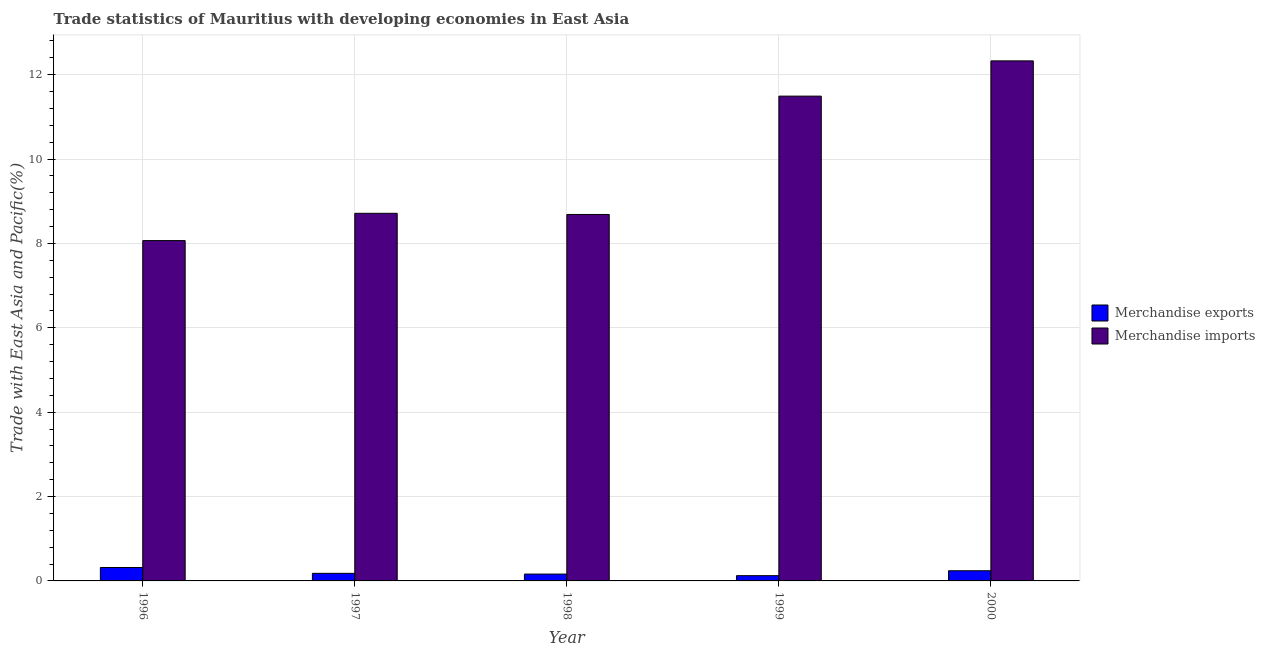How many different coloured bars are there?
Your answer should be compact. 2. Are the number of bars per tick equal to the number of legend labels?
Offer a very short reply. Yes. Are the number of bars on each tick of the X-axis equal?
Make the answer very short. Yes. How many bars are there on the 4th tick from the left?
Offer a terse response. 2. How many bars are there on the 2nd tick from the right?
Provide a succinct answer. 2. What is the merchandise exports in 2000?
Offer a terse response. 0.24. Across all years, what is the maximum merchandise imports?
Make the answer very short. 12.33. Across all years, what is the minimum merchandise imports?
Give a very brief answer. 8.07. In which year was the merchandise imports minimum?
Give a very brief answer. 1996. What is the total merchandise imports in the graph?
Make the answer very short. 49.28. What is the difference between the merchandise imports in 1997 and that in 1999?
Offer a very short reply. -2.78. What is the difference between the merchandise exports in 2000 and the merchandise imports in 1997?
Your answer should be very brief. 0.06. What is the average merchandise exports per year?
Keep it short and to the point. 0.21. What is the ratio of the merchandise imports in 1996 to that in 2000?
Offer a very short reply. 0.65. Is the merchandise exports in 1998 less than that in 1999?
Your answer should be compact. No. What is the difference between the highest and the second highest merchandise imports?
Provide a succinct answer. 0.84. What is the difference between the highest and the lowest merchandise exports?
Your answer should be very brief. 0.19. In how many years, is the merchandise exports greater than the average merchandise exports taken over all years?
Give a very brief answer. 2. Is the sum of the merchandise exports in 1996 and 1997 greater than the maximum merchandise imports across all years?
Offer a terse response. Yes. Are all the bars in the graph horizontal?
Make the answer very short. No. How many years are there in the graph?
Offer a very short reply. 5. What is the difference between two consecutive major ticks on the Y-axis?
Offer a very short reply. 2. Does the graph contain any zero values?
Make the answer very short. No. How are the legend labels stacked?
Offer a very short reply. Vertical. What is the title of the graph?
Ensure brevity in your answer.  Trade statistics of Mauritius with developing economies in East Asia. What is the label or title of the X-axis?
Your answer should be compact. Year. What is the label or title of the Y-axis?
Your answer should be very brief. Trade with East Asia and Pacific(%). What is the Trade with East Asia and Pacific(%) in Merchandise exports in 1996?
Provide a succinct answer. 0.32. What is the Trade with East Asia and Pacific(%) of Merchandise imports in 1996?
Ensure brevity in your answer.  8.07. What is the Trade with East Asia and Pacific(%) in Merchandise exports in 1997?
Give a very brief answer. 0.18. What is the Trade with East Asia and Pacific(%) in Merchandise imports in 1997?
Your response must be concise. 8.71. What is the Trade with East Asia and Pacific(%) in Merchandise exports in 1998?
Your answer should be compact. 0.16. What is the Trade with East Asia and Pacific(%) of Merchandise imports in 1998?
Offer a very short reply. 8.69. What is the Trade with East Asia and Pacific(%) of Merchandise exports in 1999?
Offer a terse response. 0.12. What is the Trade with East Asia and Pacific(%) in Merchandise imports in 1999?
Your answer should be compact. 11.49. What is the Trade with East Asia and Pacific(%) in Merchandise exports in 2000?
Keep it short and to the point. 0.24. What is the Trade with East Asia and Pacific(%) of Merchandise imports in 2000?
Your answer should be compact. 12.33. Across all years, what is the maximum Trade with East Asia and Pacific(%) in Merchandise exports?
Provide a succinct answer. 0.32. Across all years, what is the maximum Trade with East Asia and Pacific(%) in Merchandise imports?
Provide a succinct answer. 12.33. Across all years, what is the minimum Trade with East Asia and Pacific(%) of Merchandise exports?
Provide a short and direct response. 0.12. Across all years, what is the minimum Trade with East Asia and Pacific(%) of Merchandise imports?
Your answer should be compact. 8.07. What is the total Trade with East Asia and Pacific(%) of Merchandise exports in the graph?
Offer a very short reply. 1.03. What is the total Trade with East Asia and Pacific(%) in Merchandise imports in the graph?
Make the answer very short. 49.28. What is the difference between the Trade with East Asia and Pacific(%) of Merchandise exports in 1996 and that in 1997?
Your answer should be very brief. 0.14. What is the difference between the Trade with East Asia and Pacific(%) in Merchandise imports in 1996 and that in 1997?
Make the answer very short. -0.65. What is the difference between the Trade with East Asia and Pacific(%) of Merchandise exports in 1996 and that in 1998?
Make the answer very short. 0.16. What is the difference between the Trade with East Asia and Pacific(%) of Merchandise imports in 1996 and that in 1998?
Provide a short and direct response. -0.62. What is the difference between the Trade with East Asia and Pacific(%) of Merchandise exports in 1996 and that in 1999?
Your answer should be very brief. 0.19. What is the difference between the Trade with East Asia and Pacific(%) in Merchandise imports in 1996 and that in 1999?
Ensure brevity in your answer.  -3.42. What is the difference between the Trade with East Asia and Pacific(%) of Merchandise exports in 1996 and that in 2000?
Keep it short and to the point. 0.08. What is the difference between the Trade with East Asia and Pacific(%) in Merchandise imports in 1996 and that in 2000?
Provide a short and direct response. -4.26. What is the difference between the Trade with East Asia and Pacific(%) in Merchandise exports in 1997 and that in 1998?
Ensure brevity in your answer.  0.02. What is the difference between the Trade with East Asia and Pacific(%) of Merchandise imports in 1997 and that in 1998?
Your answer should be very brief. 0.03. What is the difference between the Trade with East Asia and Pacific(%) of Merchandise exports in 1997 and that in 1999?
Provide a succinct answer. 0.06. What is the difference between the Trade with East Asia and Pacific(%) of Merchandise imports in 1997 and that in 1999?
Ensure brevity in your answer.  -2.78. What is the difference between the Trade with East Asia and Pacific(%) in Merchandise exports in 1997 and that in 2000?
Provide a succinct answer. -0.06. What is the difference between the Trade with East Asia and Pacific(%) of Merchandise imports in 1997 and that in 2000?
Provide a succinct answer. -3.61. What is the difference between the Trade with East Asia and Pacific(%) in Merchandise exports in 1998 and that in 1999?
Offer a terse response. 0.04. What is the difference between the Trade with East Asia and Pacific(%) of Merchandise imports in 1998 and that in 1999?
Give a very brief answer. -2.8. What is the difference between the Trade with East Asia and Pacific(%) of Merchandise exports in 1998 and that in 2000?
Your answer should be very brief. -0.08. What is the difference between the Trade with East Asia and Pacific(%) of Merchandise imports in 1998 and that in 2000?
Keep it short and to the point. -3.64. What is the difference between the Trade with East Asia and Pacific(%) in Merchandise exports in 1999 and that in 2000?
Your answer should be compact. -0.12. What is the difference between the Trade with East Asia and Pacific(%) in Merchandise imports in 1999 and that in 2000?
Provide a short and direct response. -0.84. What is the difference between the Trade with East Asia and Pacific(%) in Merchandise exports in 1996 and the Trade with East Asia and Pacific(%) in Merchandise imports in 1997?
Offer a very short reply. -8.4. What is the difference between the Trade with East Asia and Pacific(%) of Merchandise exports in 1996 and the Trade with East Asia and Pacific(%) of Merchandise imports in 1998?
Your response must be concise. -8.37. What is the difference between the Trade with East Asia and Pacific(%) in Merchandise exports in 1996 and the Trade with East Asia and Pacific(%) in Merchandise imports in 1999?
Provide a short and direct response. -11.17. What is the difference between the Trade with East Asia and Pacific(%) of Merchandise exports in 1996 and the Trade with East Asia and Pacific(%) of Merchandise imports in 2000?
Your answer should be compact. -12.01. What is the difference between the Trade with East Asia and Pacific(%) in Merchandise exports in 1997 and the Trade with East Asia and Pacific(%) in Merchandise imports in 1998?
Offer a terse response. -8.51. What is the difference between the Trade with East Asia and Pacific(%) of Merchandise exports in 1997 and the Trade with East Asia and Pacific(%) of Merchandise imports in 1999?
Ensure brevity in your answer.  -11.31. What is the difference between the Trade with East Asia and Pacific(%) in Merchandise exports in 1997 and the Trade with East Asia and Pacific(%) in Merchandise imports in 2000?
Offer a terse response. -12.15. What is the difference between the Trade with East Asia and Pacific(%) of Merchandise exports in 1998 and the Trade with East Asia and Pacific(%) of Merchandise imports in 1999?
Keep it short and to the point. -11.33. What is the difference between the Trade with East Asia and Pacific(%) in Merchandise exports in 1998 and the Trade with East Asia and Pacific(%) in Merchandise imports in 2000?
Your response must be concise. -12.16. What is the difference between the Trade with East Asia and Pacific(%) of Merchandise exports in 1999 and the Trade with East Asia and Pacific(%) of Merchandise imports in 2000?
Keep it short and to the point. -12.2. What is the average Trade with East Asia and Pacific(%) in Merchandise exports per year?
Provide a short and direct response. 0.21. What is the average Trade with East Asia and Pacific(%) in Merchandise imports per year?
Offer a very short reply. 9.86. In the year 1996, what is the difference between the Trade with East Asia and Pacific(%) in Merchandise exports and Trade with East Asia and Pacific(%) in Merchandise imports?
Your answer should be very brief. -7.75. In the year 1997, what is the difference between the Trade with East Asia and Pacific(%) of Merchandise exports and Trade with East Asia and Pacific(%) of Merchandise imports?
Give a very brief answer. -8.53. In the year 1998, what is the difference between the Trade with East Asia and Pacific(%) in Merchandise exports and Trade with East Asia and Pacific(%) in Merchandise imports?
Provide a short and direct response. -8.52. In the year 1999, what is the difference between the Trade with East Asia and Pacific(%) of Merchandise exports and Trade with East Asia and Pacific(%) of Merchandise imports?
Make the answer very short. -11.37. In the year 2000, what is the difference between the Trade with East Asia and Pacific(%) of Merchandise exports and Trade with East Asia and Pacific(%) of Merchandise imports?
Offer a very short reply. -12.09. What is the ratio of the Trade with East Asia and Pacific(%) of Merchandise exports in 1996 to that in 1997?
Provide a succinct answer. 1.77. What is the ratio of the Trade with East Asia and Pacific(%) in Merchandise imports in 1996 to that in 1997?
Your response must be concise. 0.93. What is the ratio of the Trade with East Asia and Pacific(%) of Merchandise exports in 1996 to that in 1998?
Provide a short and direct response. 1.96. What is the ratio of the Trade with East Asia and Pacific(%) of Merchandise imports in 1996 to that in 1998?
Your answer should be compact. 0.93. What is the ratio of the Trade with East Asia and Pacific(%) in Merchandise exports in 1996 to that in 1999?
Give a very brief answer. 2.56. What is the ratio of the Trade with East Asia and Pacific(%) in Merchandise imports in 1996 to that in 1999?
Keep it short and to the point. 0.7. What is the ratio of the Trade with East Asia and Pacific(%) of Merchandise exports in 1996 to that in 2000?
Your answer should be very brief. 1.32. What is the ratio of the Trade with East Asia and Pacific(%) of Merchandise imports in 1996 to that in 2000?
Provide a succinct answer. 0.65. What is the ratio of the Trade with East Asia and Pacific(%) in Merchandise exports in 1997 to that in 1998?
Your response must be concise. 1.11. What is the ratio of the Trade with East Asia and Pacific(%) in Merchandise exports in 1997 to that in 1999?
Provide a short and direct response. 1.44. What is the ratio of the Trade with East Asia and Pacific(%) in Merchandise imports in 1997 to that in 1999?
Your answer should be compact. 0.76. What is the ratio of the Trade with East Asia and Pacific(%) in Merchandise exports in 1997 to that in 2000?
Your answer should be very brief. 0.75. What is the ratio of the Trade with East Asia and Pacific(%) of Merchandise imports in 1997 to that in 2000?
Your answer should be very brief. 0.71. What is the ratio of the Trade with East Asia and Pacific(%) of Merchandise exports in 1998 to that in 1999?
Your answer should be compact. 1.3. What is the ratio of the Trade with East Asia and Pacific(%) in Merchandise imports in 1998 to that in 1999?
Make the answer very short. 0.76. What is the ratio of the Trade with East Asia and Pacific(%) in Merchandise exports in 1998 to that in 2000?
Provide a short and direct response. 0.67. What is the ratio of the Trade with East Asia and Pacific(%) in Merchandise imports in 1998 to that in 2000?
Give a very brief answer. 0.7. What is the ratio of the Trade with East Asia and Pacific(%) in Merchandise exports in 1999 to that in 2000?
Your response must be concise. 0.52. What is the ratio of the Trade with East Asia and Pacific(%) in Merchandise imports in 1999 to that in 2000?
Your answer should be compact. 0.93. What is the difference between the highest and the second highest Trade with East Asia and Pacific(%) in Merchandise exports?
Provide a succinct answer. 0.08. What is the difference between the highest and the second highest Trade with East Asia and Pacific(%) in Merchandise imports?
Offer a very short reply. 0.84. What is the difference between the highest and the lowest Trade with East Asia and Pacific(%) in Merchandise exports?
Ensure brevity in your answer.  0.19. What is the difference between the highest and the lowest Trade with East Asia and Pacific(%) of Merchandise imports?
Provide a succinct answer. 4.26. 